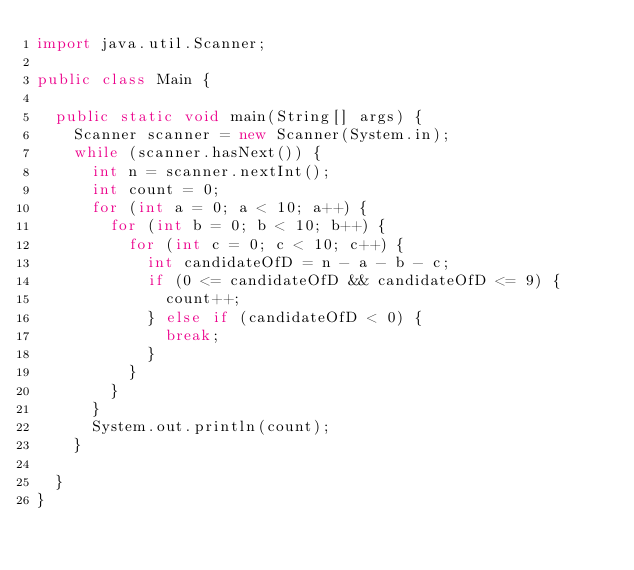Convert code to text. <code><loc_0><loc_0><loc_500><loc_500><_Java_>import java.util.Scanner;

public class Main {

  public static void main(String[] args) {
    Scanner scanner = new Scanner(System.in);
    while (scanner.hasNext()) {
      int n = scanner.nextInt();
      int count = 0;
      for (int a = 0; a < 10; a++) {
        for (int b = 0; b < 10; b++) {
          for (int c = 0; c < 10; c++) {
            int candidateOfD = n - a - b - c;
            if (0 <= candidateOfD && candidateOfD <= 9) {
              count++;
            } else if (candidateOfD < 0) {
              break;
            }
          }
        }
      }
      System.out.println(count);
    }

  }
}

</code> 